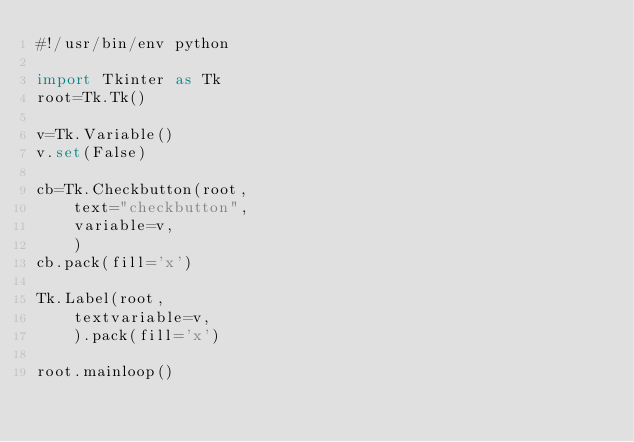Convert code to text. <code><loc_0><loc_0><loc_500><loc_500><_Python_>#!/usr/bin/env python

import Tkinter as Tk
root=Tk.Tk()

v=Tk.Variable()
v.set(False)

cb=Tk.Checkbutton(root,
    text="checkbutton",
    variable=v,
    )
cb.pack(fill='x')

Tk.Label(root,
    textvariable=v,
    ).pack(fill='x')

root.mainloop()
</code> 